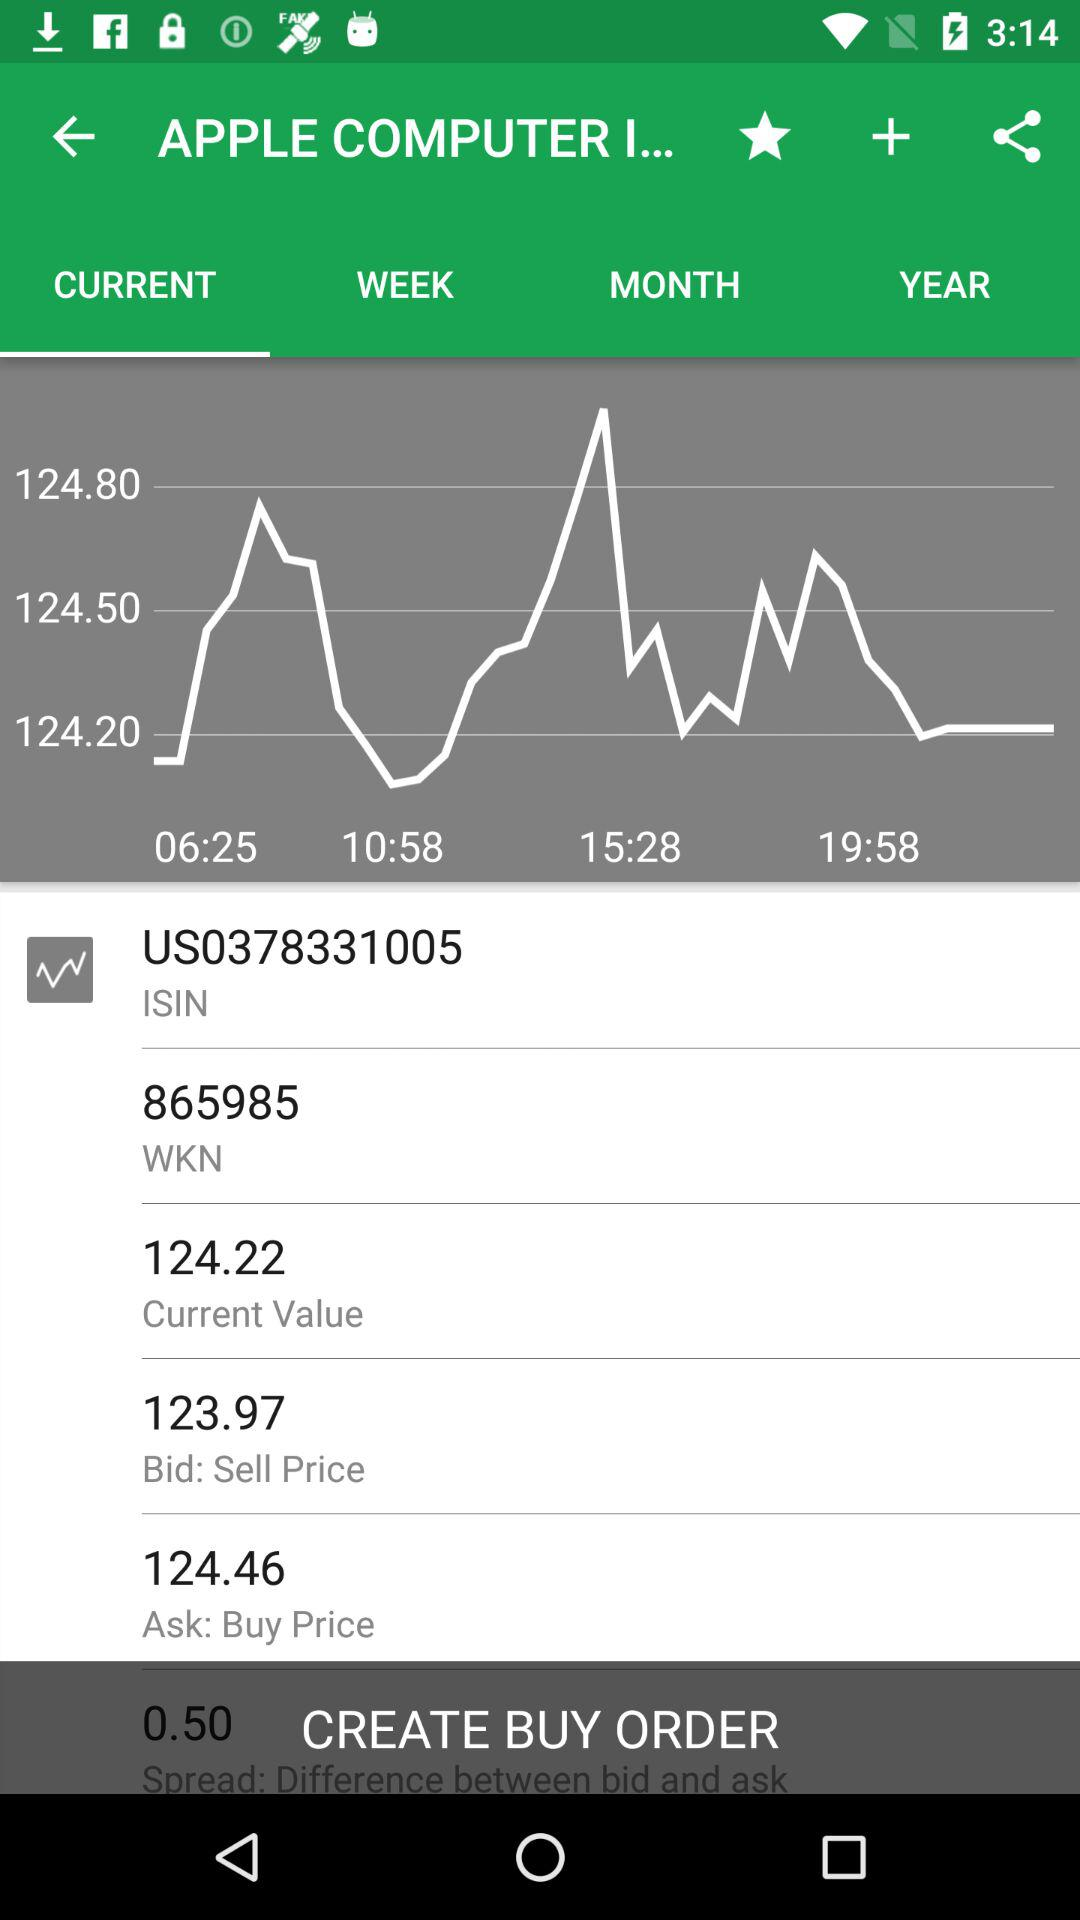Which tab is selected? The selected tab is "CURRENT". 